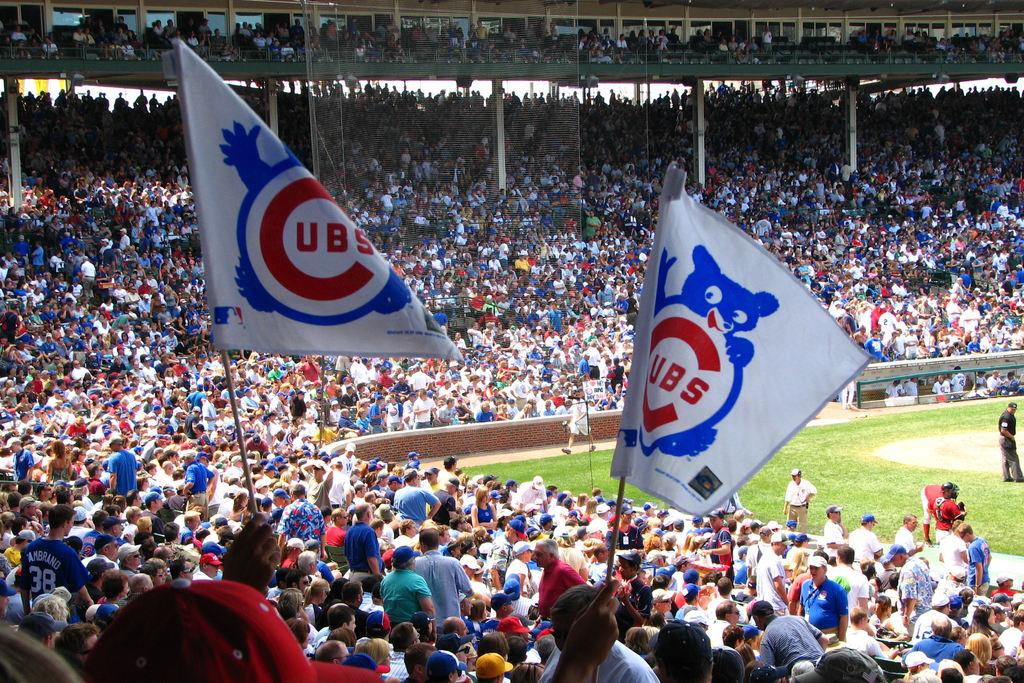How many people are present in the image? There are many people in the image. What are some people holding in the image? Some people are holding flags in the image. Where is the image set? The image is set in a stadium. What type of surface is visible in the image? There is a ground in the image. What kind of structure can be seen in the image? There is a net-like structure in the image. What type of amusement ride can be seen in the image? There is no amusement ride present in the image; it is set in a stadium with people holding flags. How does the brake system work in the image? There is no brake system present in the image, as it is set in a stadium with people holding flags. 